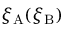Convert formula to latex. <formula><loc_0><loc_0><loc_500><loc_500>\xi _ { A } ( \xi _ { B } )</formula> 